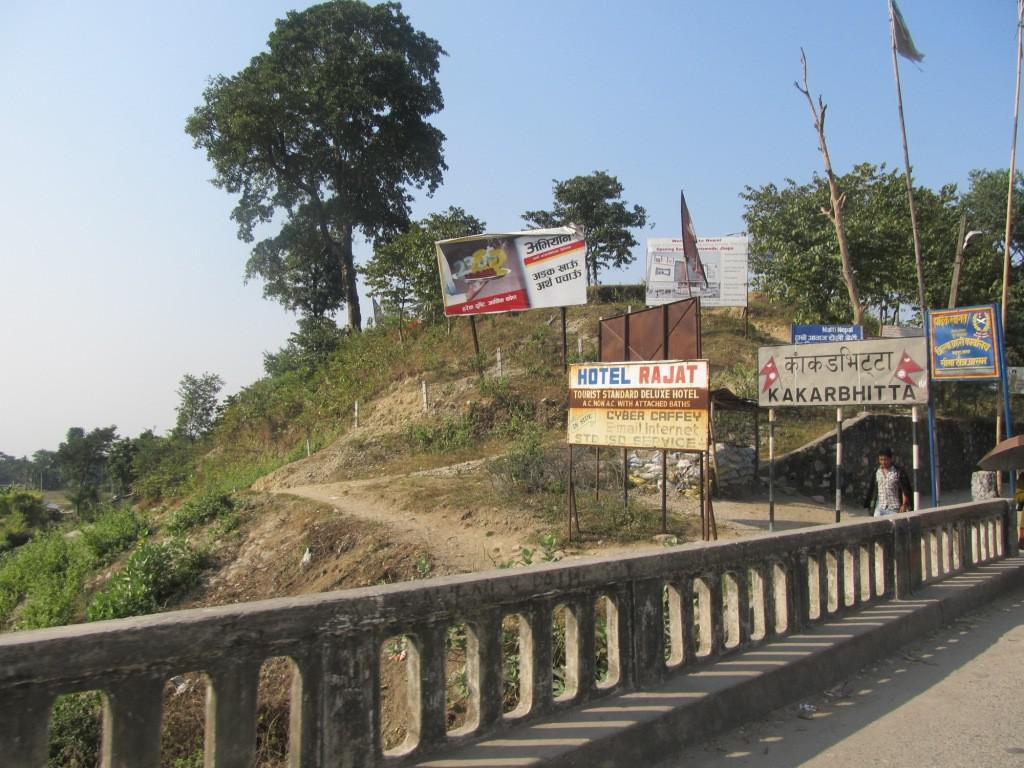<image>
Write a terse but informative summary of the picture. a sign that says the word hotel on it 